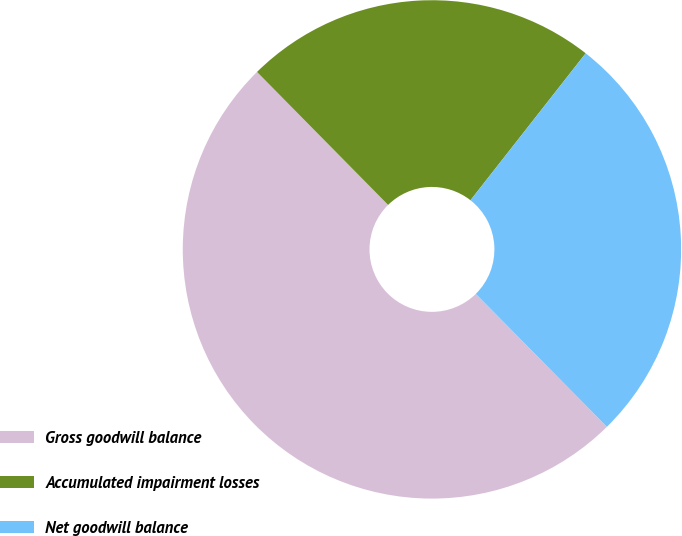Convert chart to OTSL. <chart><loc_0><loc_0><loc_500><loc_500><pie_chart><fcel>Gross goodwill balance<fcel>Accumulated impairment losses<fcel>Net goodwill balance<nl><fcel>50.0%<fcel>22.97%<fcel>27.03%<nl></chart> 